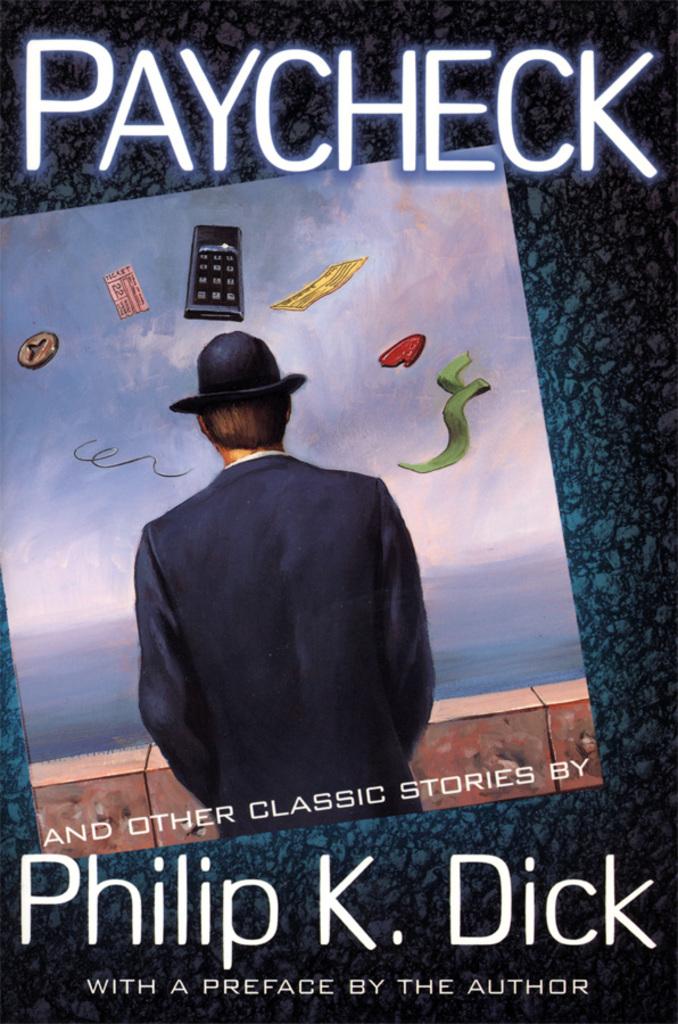What is the title of the book?
Offer a very short reply. Paycheck. 